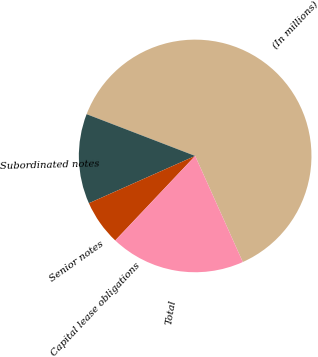Convert chart to OTSL. <chart><loc_0><loc_0><loc_500><loc_500><pie_chart><fcel>(In millions)<fcel>Subordinated notes<fcel>Senior notes<fcel>Capital lease obligations<fcel>Total<nl><fcel>62.43%<fcel>12.51%<fcel>6.27%<fcel>0.03%<fcel>18.75%<nl></chart> 